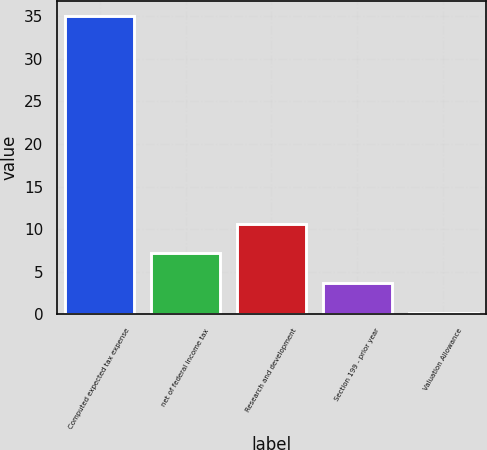Convert chart to OTSL. <chart><loc_0><loc_0><loc_500><loc_500><bar_chart><fcel>Computed expected tax expense<fcel>net of federal income tax<fcel>Research and development<fcel>Section 199 - prior year<fcel>Valuation Allowance<nl><fcel>35<fcel>7.16<fcel>10.64<fcel>3.68<fcel>0.2<nl></chart> 